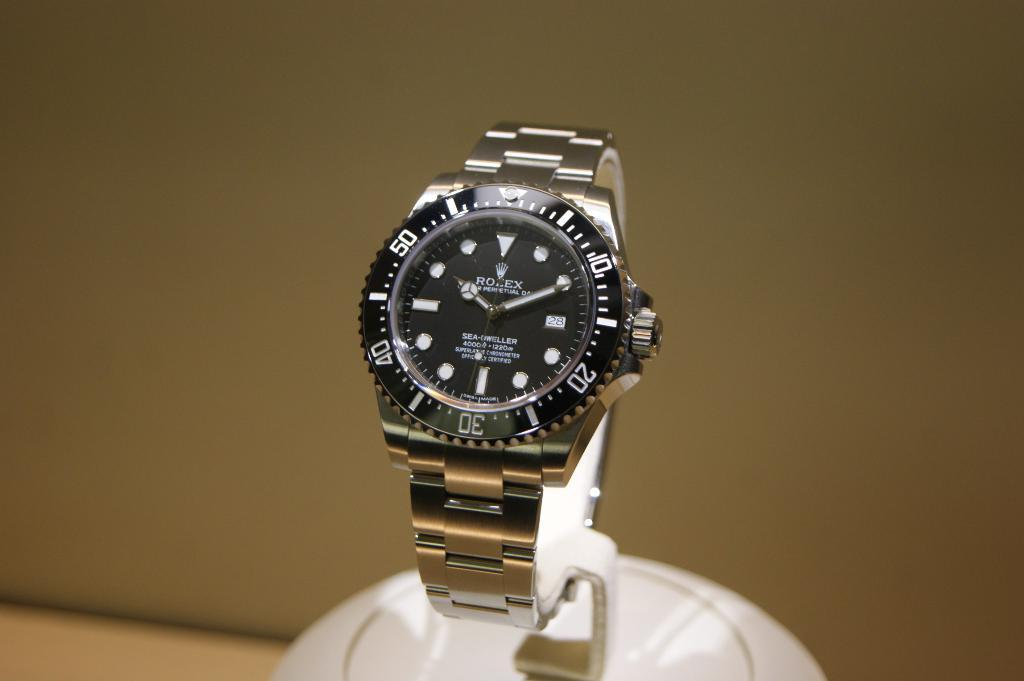Provide a one-sentence caption for the provided image. A displayed Rolex watch shows the time of 10:11. 